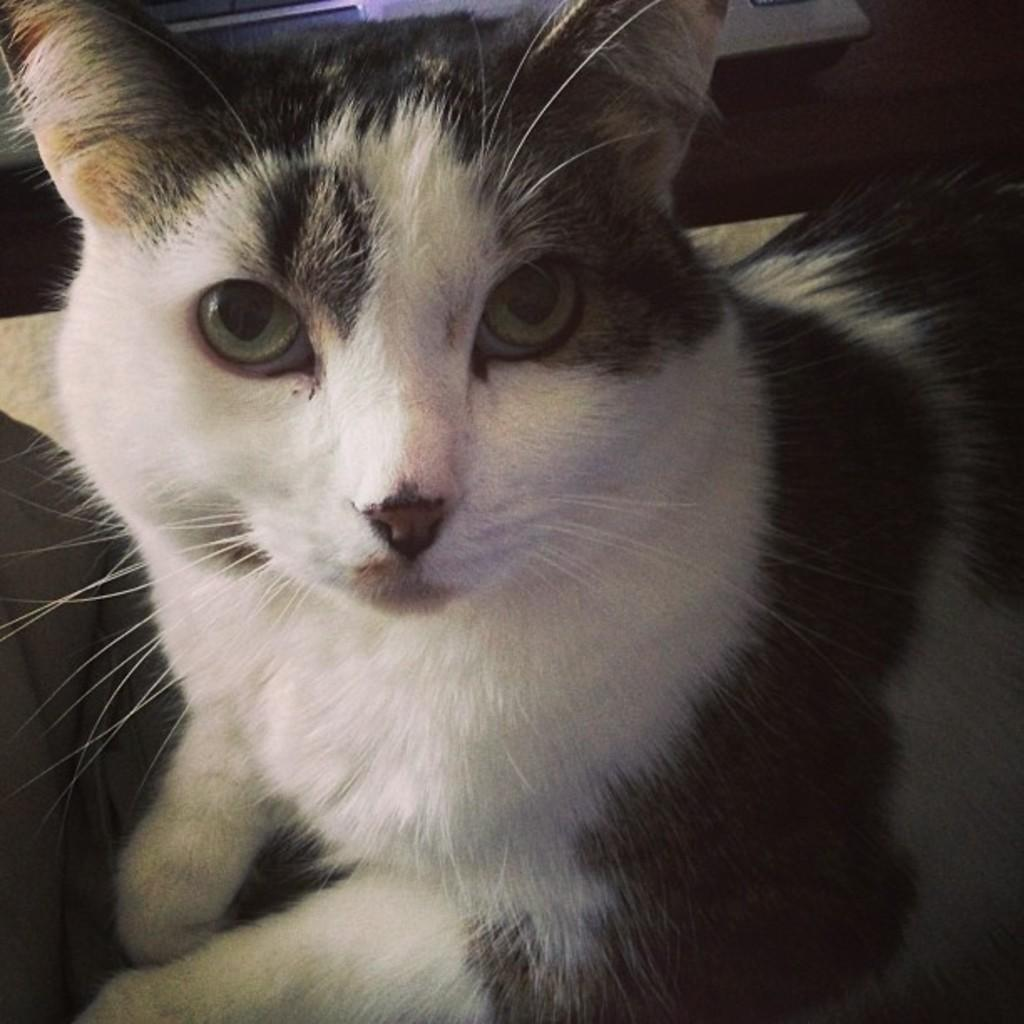What type of animal is in the picture? There is a cat in the picture. Can you describe the color of the cat? The cat is white and black in color. What type of dish is the cat cooking in the image? There is no dish or cooking activity present in the image; it features a cat. 